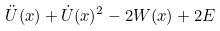<formula> <loc_0><loc_0><loc_500><loc_500>\ddot { U } ( x ) + \dot { U } ( x ) ^ { 2 } - 2 W ( x ) + 2 E</formula> 